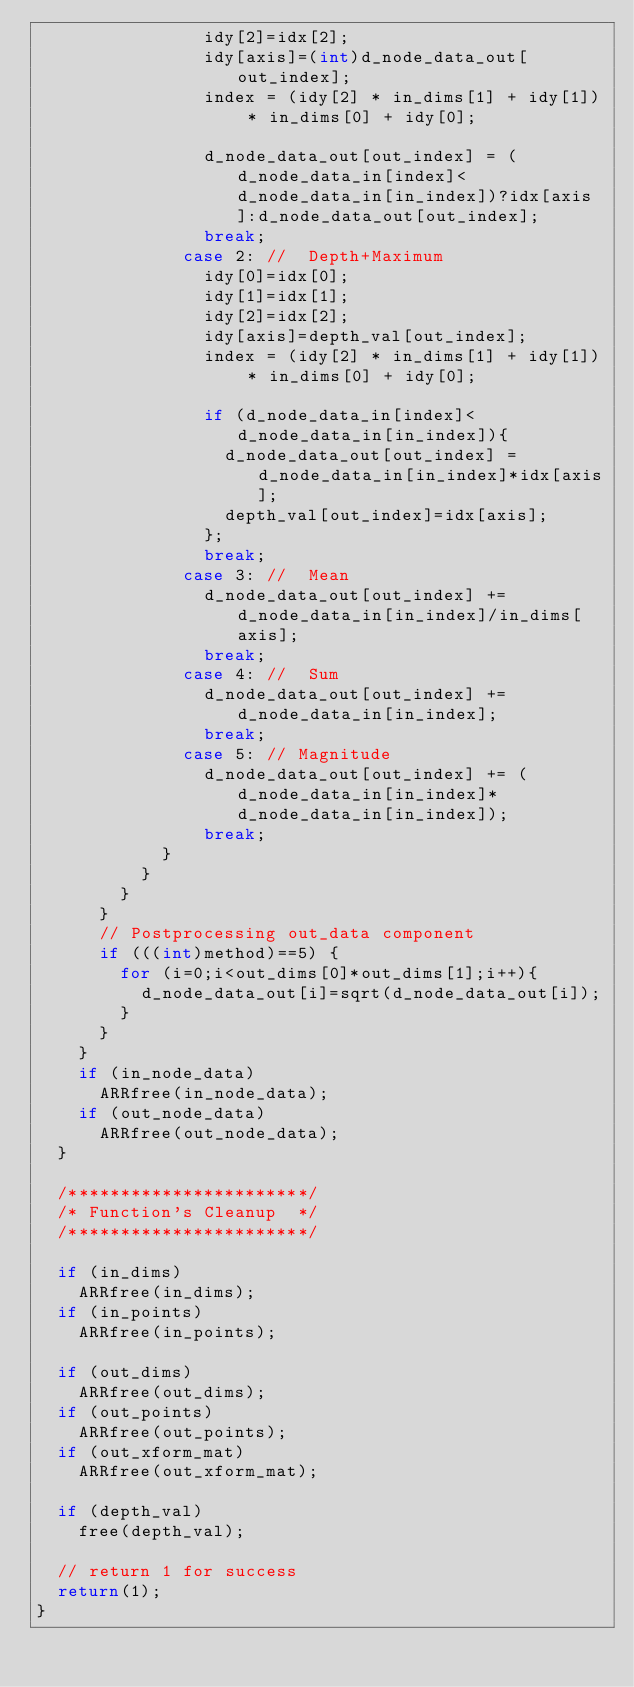<code> <loc_0><loc_0><loc_500><loc_500><_C++_>								idy[2]=idx[2];
								idy[axis]=(int)d_node_data_out[out_index];
								index = (idy[2] * in_dims[1] + idy[1]) * in_dims[0] + idy[0];							
								d_node_data_out[out_index] = (d_node_data_in[index]<d_node_data_in[in_index])?idx[axis]:d_node_data_out[out_index];
								break; 
							case 2:	//	Depth+Maximum
								idy[0]=idx[0];
								idy[1]=idx[1];
								idy[2]=idx[2];
								idy[axis]=depth_val[out_index];
								index = (idy[2] * in_dims[1] + idy[1]) * in_dims[0] + idy[0];							
								if (d_node_data_in[index]<d_node_data_in[in_index]){
									d_node_data_out[out_index] = d_node_data_in[in_index]*idx[axis];
									depth_val[out_index]=idx[axis];
								};
								break; 
							case 3:	//	Mean
								d_node_data_out[out_index] += d_node_data_in[in_index]/in_dims[axis];
								break; 						
							case 4:	//	Sum
								d_node_data_out[out_index] += d_node_data_in[in_index];
								break; 
							case 5: // Magnitude
								d_node_data_out[out_index] += (d_node_data_in[in_index]*d_node_data_in[in_index]);
								break;
						}
					}
				}
			}
			// Postprocessing out_data component
			if (((int)method)==5) {
				for (i=0;i<out_dims[0]*out_dims[1];i++){
					d_node_data_out[i]=sqrt(d_node_data_out[i]);
				}
			}
		}
		if (in_node_data)
			ARRfree(in_node_data);
		if (out_node_data)
			ARRfree(out_node_data);
	}
	
	/***********************/
	/* Function's Cleanup  */
	/***********************/

	if (in_dims)
		ARRfree(in_dims);
	if (in_points)
		ARRfree(in_points);

	if (out_dims)
		ARRfree(out_dims);
	if (out_points)
		ARRfree(out_points);		
	if (out_xform_mat)
		ARRfree(out_xform_mat);
		
	if (depth_val)
		free(depth_val);

	// return 1 for success
	return(1);
}
</code> 